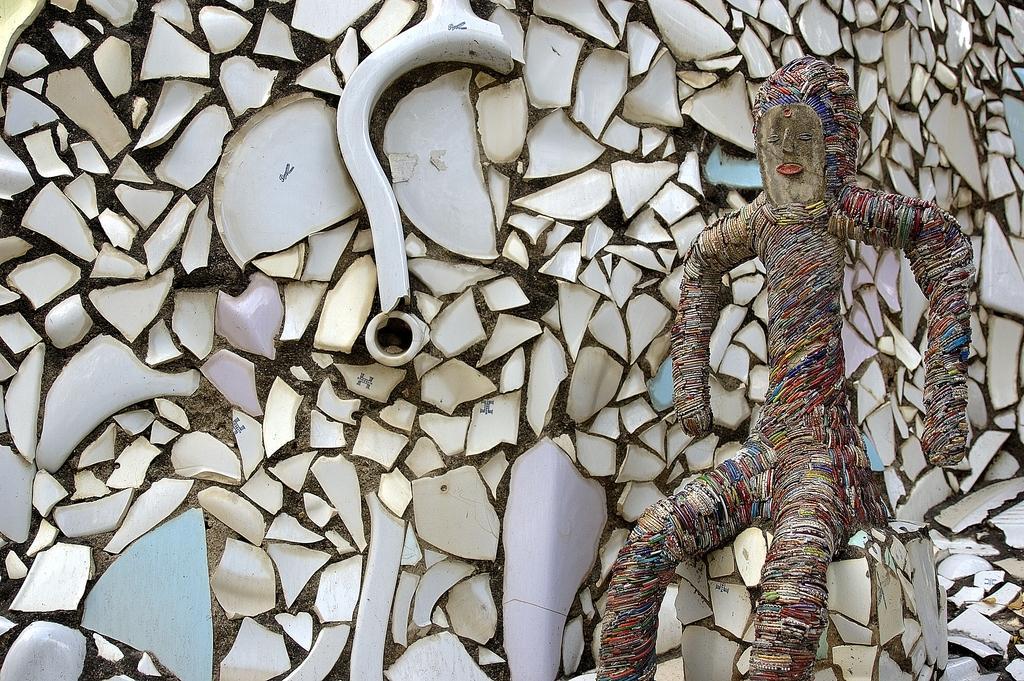Describe this image in one or two sentences. In this image we can see the sculpture in the sitting position. 